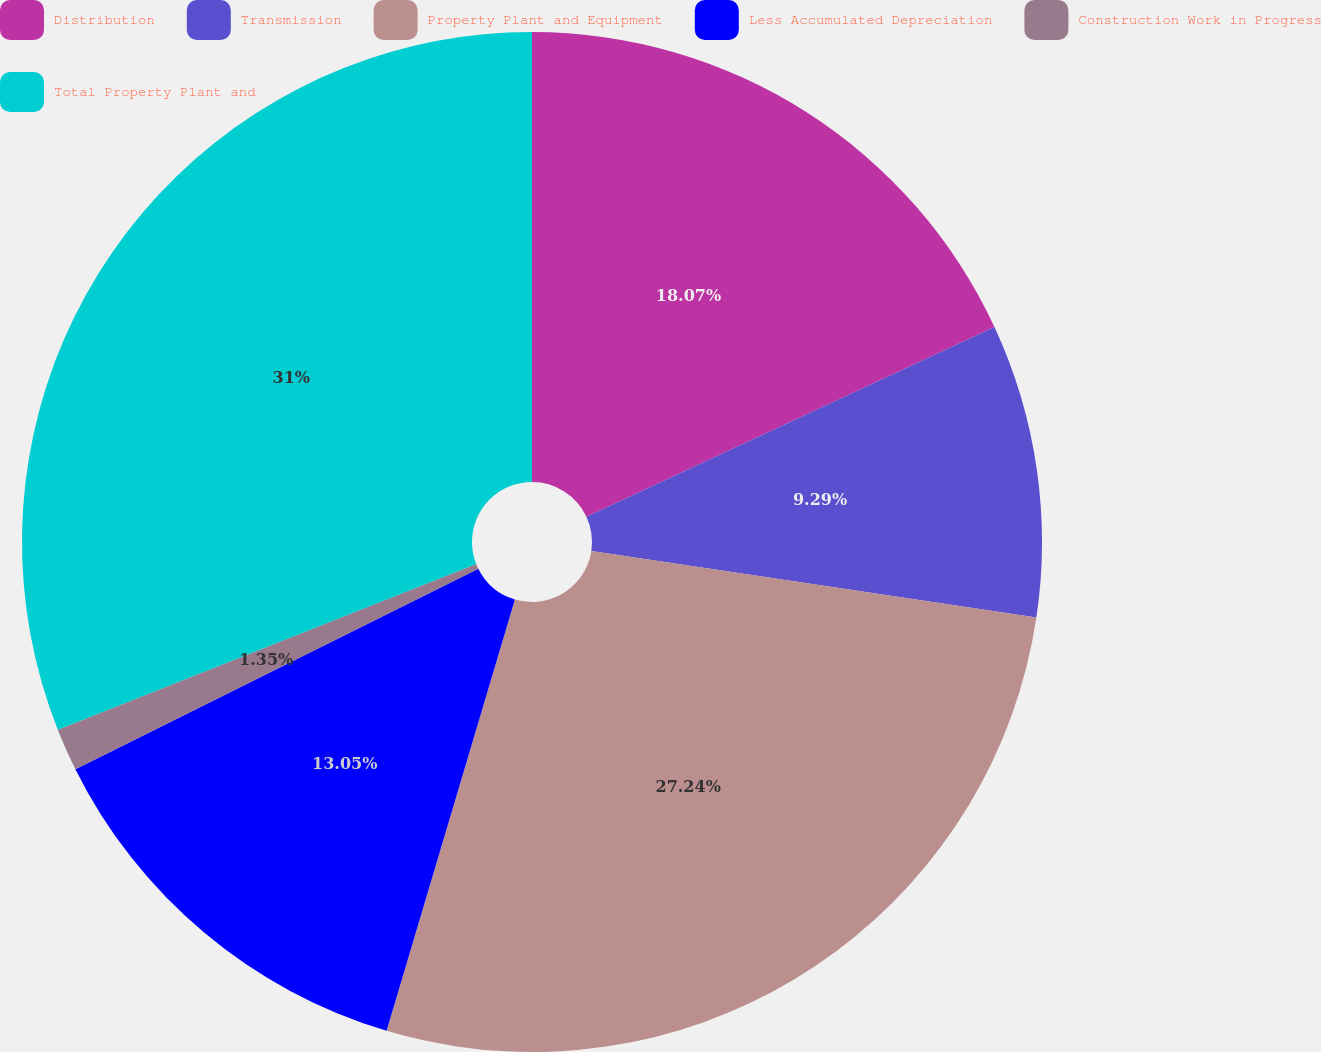<chart> <loc_0><loc_0><loc_500><loc_500><pie_chart><fcel>Distribution<fcel>Transmission<fcel>Property Plant and Equipment<fcel>Less Accumulated Depreciation<fcel>Construction Work in Progress<fcel>Total Property Plant and<nl><fcel>18.07%<fcel>9.29%<fcel>27.23%<fcel>13.05%<fcel>1.35%<fcel>30.99%<nl></chart> 